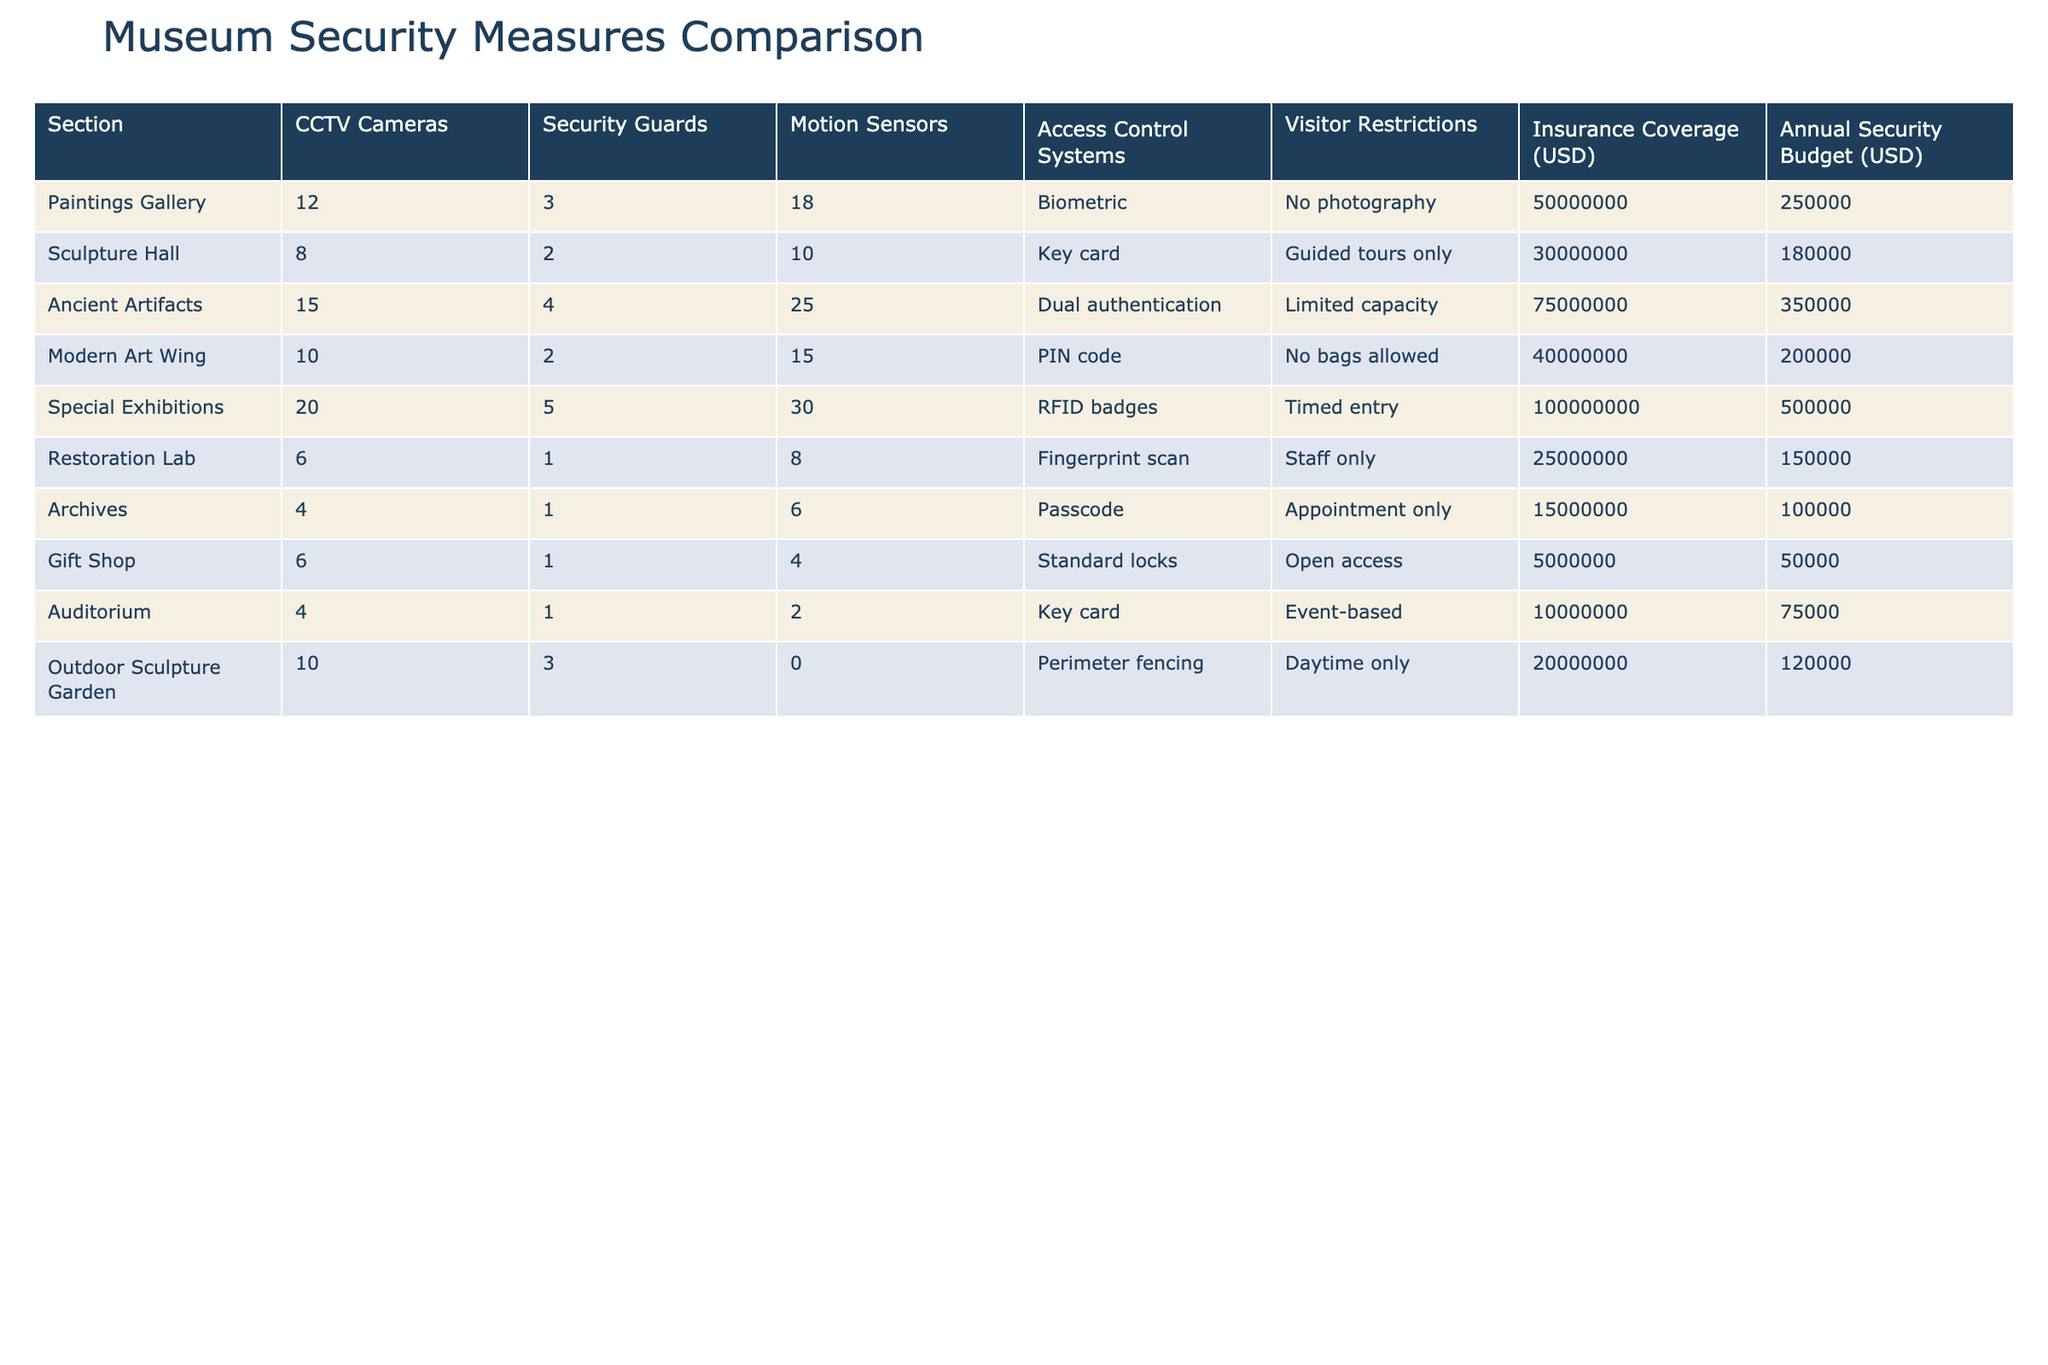What is the total number of CCTV cameras in the museum? To find the total number of CCTV cameras, we need to sum the values in the "CCTV Cameras" column: 12 (Paintings Gallery) + 8 (Sculpture Hall) + 15 (Ancient Artifacts) + 10 (Modern Art Wing) + 20 (Special Exhibitions) + 6 (Restoration Lab) + 4 (Archives) + 6 (Gift Shop) + 4 (Auditorium) + 10 (Outdoor Sculpture Garden) = 95.
Answer: 95 Which section has the highest insurance coverage? We look at the "Insurance Coverage (USD)" column and see which value is the highest. The maximum value is 100,000,000 from the "Special Exhibitions" section.
Answer: Special Exhibitions How many more security guards are there in the Paintings Gallery than in the Restoration Lab? The number of security guards in the Paintings Gallery is 3, while in the Restoration Lab it is 1. The difference is 3 - 1 = 2.
Answer: 2 Is there a security system in place that restricts photography in any museum section? The "Paintings Gallery" has "No photography" as a restriction under "Visitor Restrictions." Thus, there is a section with such a restriction.
Answer: Yes What is the average annual security budget across all museum sections? To calculate the average, we first sum the values in the "Annual Security Budget (USD)" column: 250,000 + 180,000 + 350,000 + 200,000 + 500,000 + 150,000 + 100,000 + 50,000 + 75,000 + 120,000 = 1,625,000. There are 10 sections, so the average is 1,625,000 / 10 = 162,500.
Answer: 162,500 Which section employs the least number of motion sensors? We look through the "Motion Sensors" column and find that the "Outdoor Sculpture Garden" has the least with 0 motion sensors.
Answer: Outdoor Sculpture Garden Do all sections have access control systems? Checking the "Access Control Systems" column, we see that the "Outdoor Sculpture Garden" only has "Perimeter fencing," which is not an access control system. This indicates that not all sections have access control systems.
Answer: No Which section has the highest number of motion sensors and security guards combined? We need to add the values from both the "Motion Sensors" and "Security Guards" columns for each section. The "Special Exhibitions" has 30 motion sensors and 5 security guards; their sum is 35. We check other sections, and none surpass this total.
Answer: Special Exhibitions 